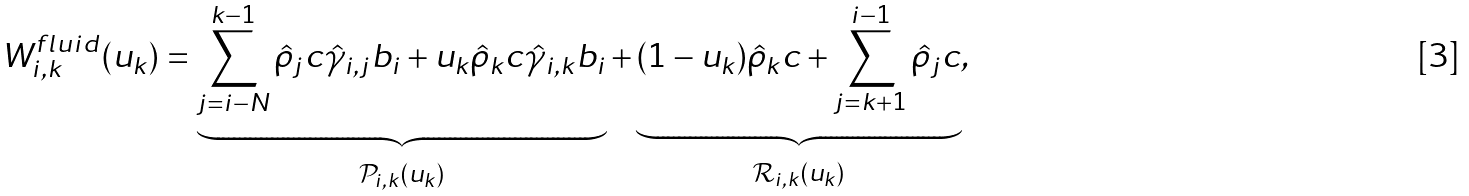Convert formula to latex. <formula><loc_0><loc_0><loc_500><loc_500>W _ { i , k } ^ { f l u i d } ( u _ { k } ) = \underbrace { \sum _ { j = i - N } ^ { k - 1 } \hat { \rho } _ { j } c \hat { \gamma } _ { i , j } b _ { i } + u _ { k } \hat { \rho } _ { k } c \hat { \gamma } _ { i , k } b _ { i } } _ { \mathcal { P } _ { i , k } ( u _ { k } ) } + \underbrace { ( 1 - u _ { k } ) \hat { \rho } _ { k } c + \sum _ { j = k + 1 } ^ { i - 1 } \hat { \rho } _ { j } c } _ { \mathcal { R } _ { i , k } ( u _ { k } ) } ,</formula> 